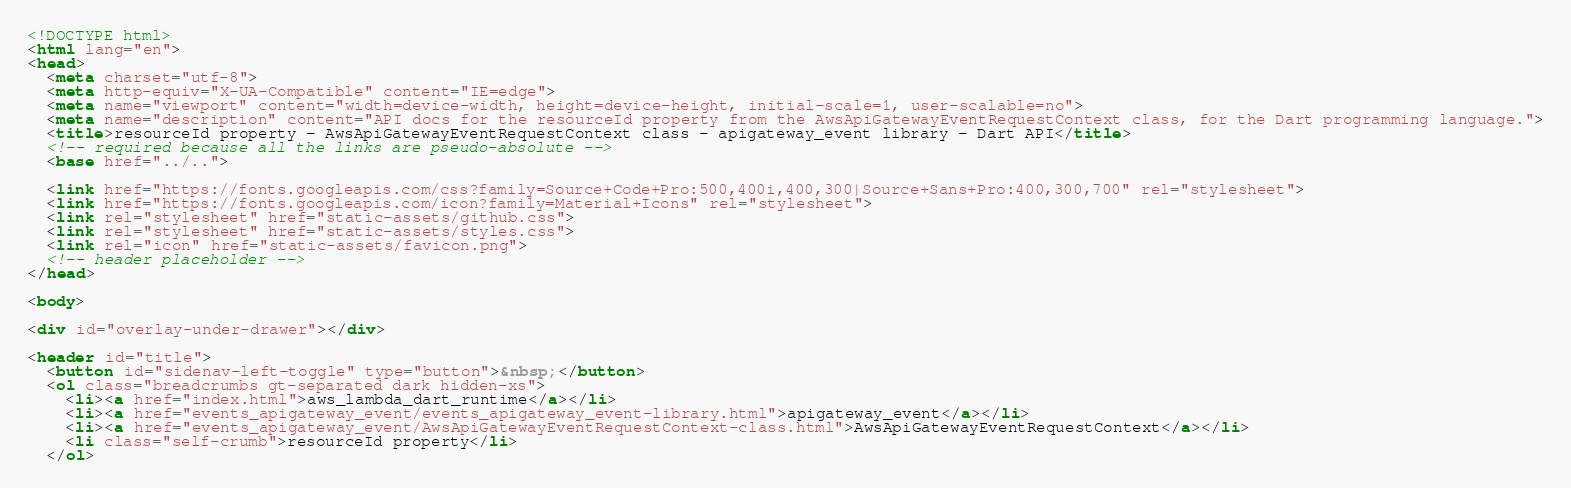Convert code to text. <code><loc_0><loc_0><loc_500><loc_500><_HTML_><!DOCTYPE html>
<html lang="en">
<head>
  <meta charset="utf-8">
  <meta http-equiv="X-UA-Compatible" content="IE=edge">
  <meta name="viewport" content="width=device-width, height=device-height, initial-scale=1, user-scalable=no">
  <meta name="description" content="API docs for the resourceId property from the AwsApiGatewayEventRequestContext class, for the Dart programming language.">
  <title>resourceId property - AwsApiGatewayEventRequestContext class - apigateway_event library - Dart API</title>
  <!-- required because all the links are pseudo-absolute -->
  <base href="../..">

  <link href="https://fonts.googleapis.com/css?family=Source+Code+Pro:500,400i,400,300|Source+Sans+Pro:400,300,700" rel="stylesheet">
  <link href="https://fonts.googleapis.com/icon?family=Material+Icons" rel="stylesheet">
  <link rel="stylesheet" href="static-assets/github.css">
  <link rel="stylesheet" href="static-assets/styles.css">
  <link rel="icon" href="static-assets/favicon.png">
  <!-- header placeholder -->
</head>

<body>

<div id="overlay-under-drawer"></div>

<header id="title">
  <button id="sidenav-left-toggle" type="button">&nbsp;</button>
  <ol class="breadcrumbs gt-separated dark hidden-xs">
    <li><a href="index.html">aws_lambda_dart_runtime</a></li>
    <li><a href="events_apigateway_event/events_apigateway_event-library.html">apigateway_event</a></li>
    <li><a href="events_apigateway_event/AwsApiGatewayEventRequestContext-class.html">AwsApiGatewayEventRequestContext</a></li>
    <li class="self-crumb">resourceId property</li>
  </ol></code> 